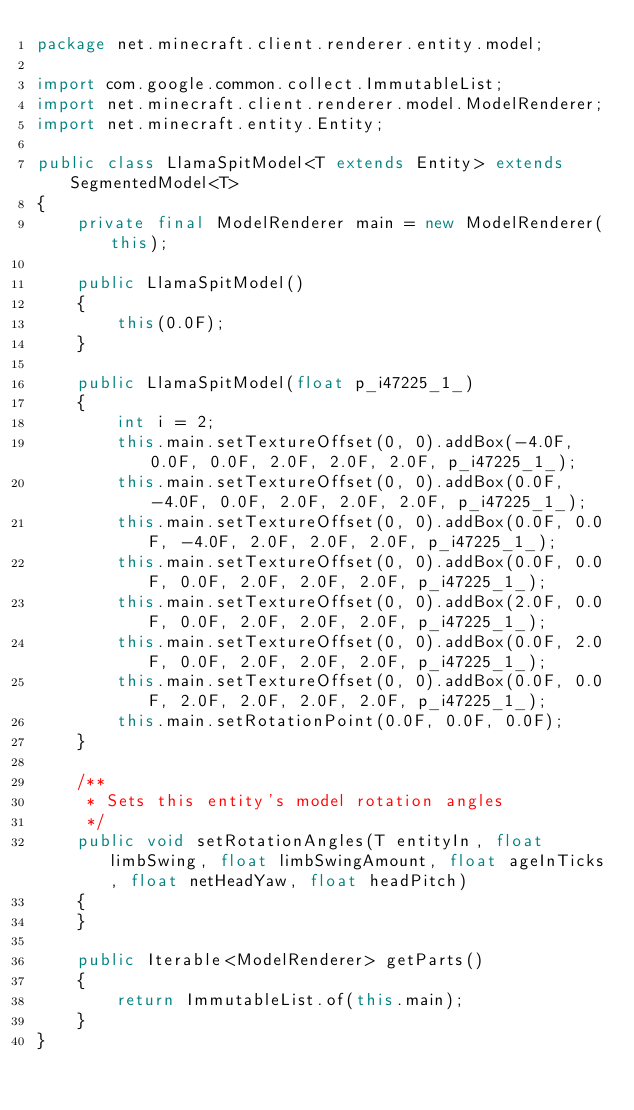Convert code to text. <code><loc_0><loc_0><loc_500><loc_500><_Java_>package net.minecraft.client.renderer.entity.model;

import com.google.common.collect.ImmutableList;
import net.minecraft.client.renderer.model.ModelRenderer;
import net.minecraft.entity.Entity;

public class LlamaSpitModel<T extends Entity> extends SegmentedModel<T>
{
    private final ModelRenderer main = new ModelRenderer(this);

    public LlamaSpitModel()
    {
        this(0.0F);
    }

    public LlamaSpitModel(float p_i47225_1_)
    {
        int i = 2;
        this.main.setTextureOffset(0, 0).addBox(-4.0F, 0.0F, 0.0F, 2.0F, 2.0F, 2.0F, p_i47225_1_);
        this.main.setTextureOffset(0, 0).addBox(0.0F, -4.0F, 0.0F, 2.0F, 2.0F, 2.0F, p_i47225_1_);
        this.main.setTextureOffset(0, 0).addBox(0.0F, 0.0F, -4.0F, 2.0F, 2.0F, 2.0F, p_i47225_1_);
        this.main.setTextureOffset(0, 0).addBox(0.0F, 0.0F, 0.0F, 2.0F, 2.0F, 2.0F, p_i47225_1_);
        this.main.setTextureOffset(0, 0).addBox(2.0F, 0.0F, 0.0F, 2.0F, 2.0F, 2.0F, p_i47225_1_);
        this.main.setTextureOffset(0, 0).addBox(0.0F, 2.0F, 0.0F, 2.0F, 2.0F, 2.0F, p_i47225_1_);
        this.main.setTextureOffset(0, 0).addBox(0.0F, 0.0F, 2.0F, 2.0F, 2.0F, 2.0F, p_i47225_1_);
        this.main.setRotationPoint(0.0F, 0.0F, 0.0F);
    }

    /**
     * Sets this entity's model rotation angles
     */
    public void setRotationAngles(T entityIn, float limbSwing, float limbSwingAmount, float ageInTicks, float netHeadYaw, float headPitch)
    {
    }

    public Iterable<ModelRenderer> getParts()
    {
        return ImmutableList.of(this.main);
    }
}
</code> 